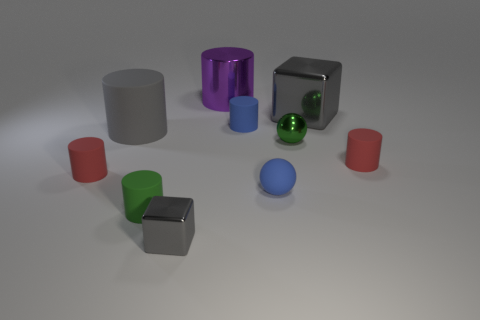Subtract all purple cylinders. How many cylinders are left? 5 Subtract all big purple cylinders. How many cylinders are left? 5 Subtract all purple cylinders. Subtract all brown balls. How many cylinders are left? 5 Subtract all spheres. How many objects are left? 8 Add 7 tiny gray things. How many tiny gray things are left? 8 Add 5 red metal cylinders. How many red metal cylinders exist? 5 Subtract 0 brown balls. How many objects are left? 10 Subtract all rubber spheres. Subtract all tiny green things. How many objects are left? 7 